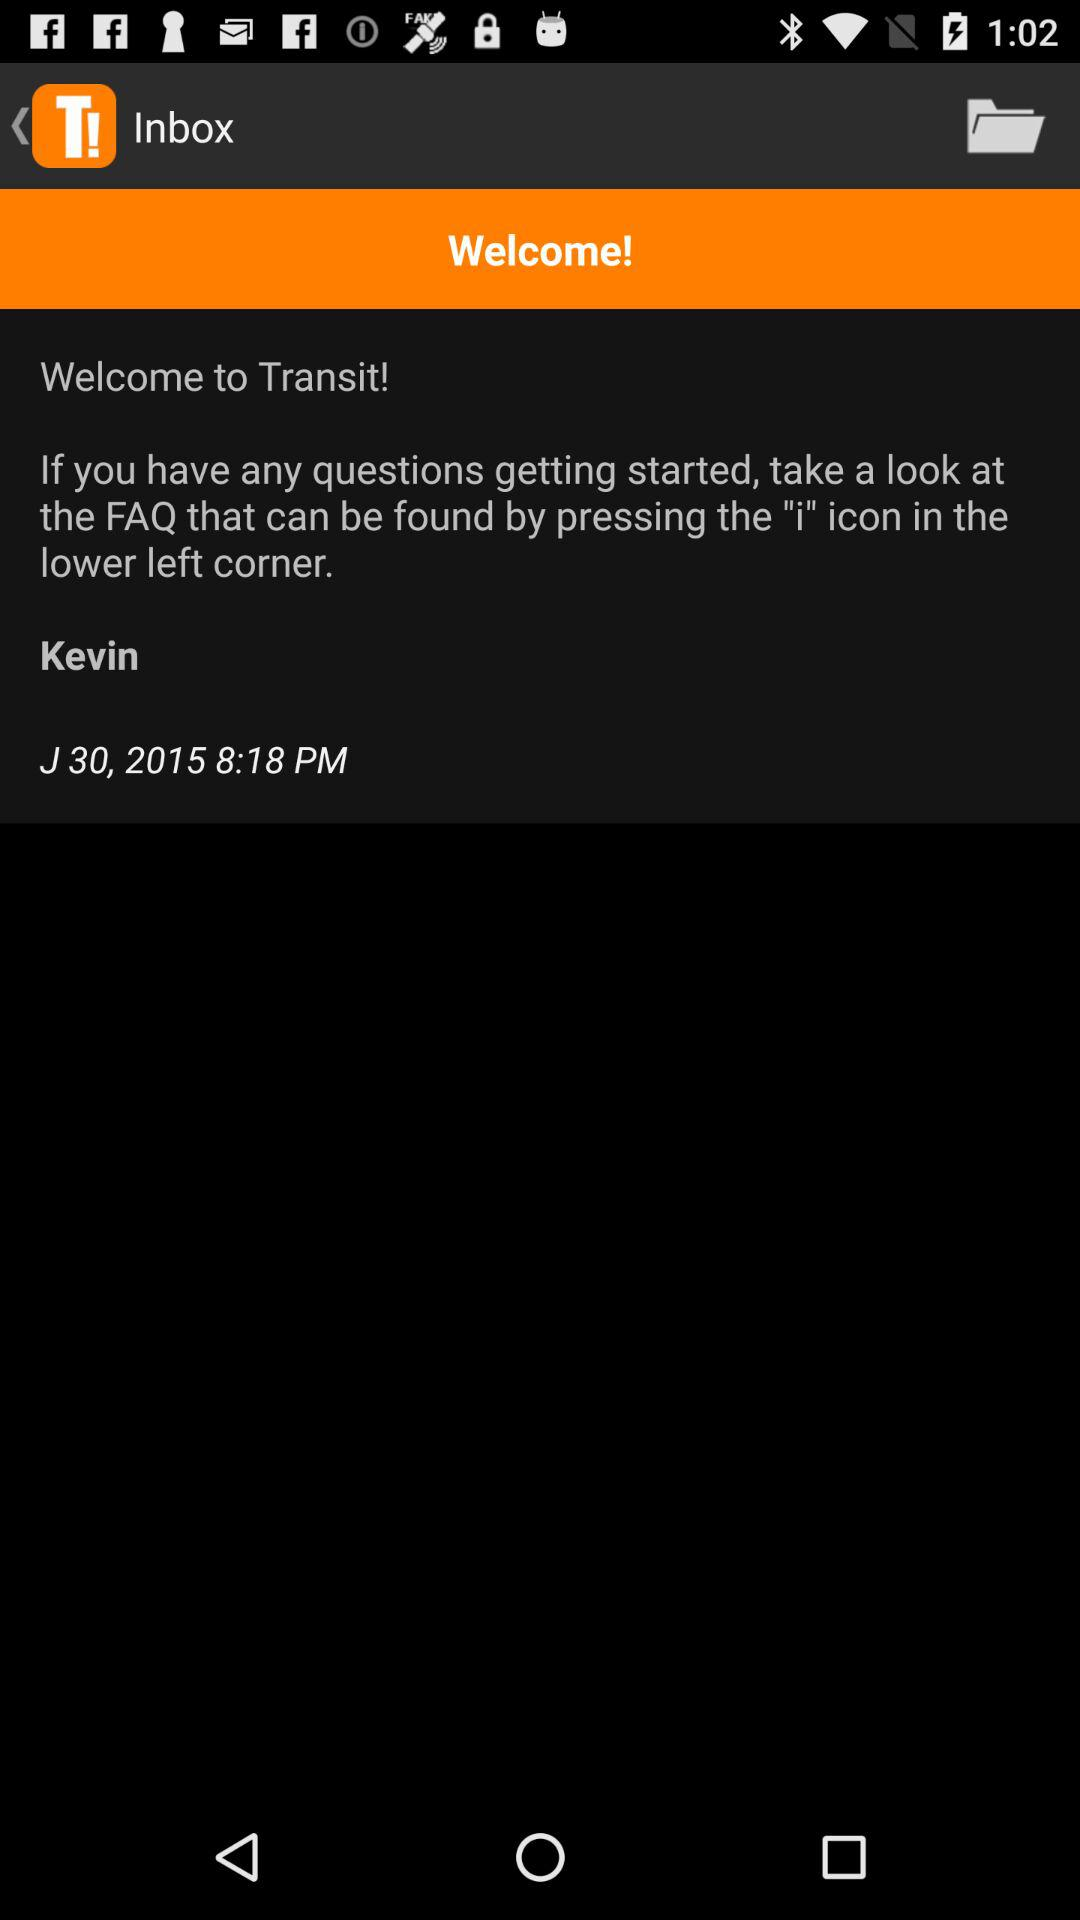What is the name of the user? The name of the user is Kevin. 